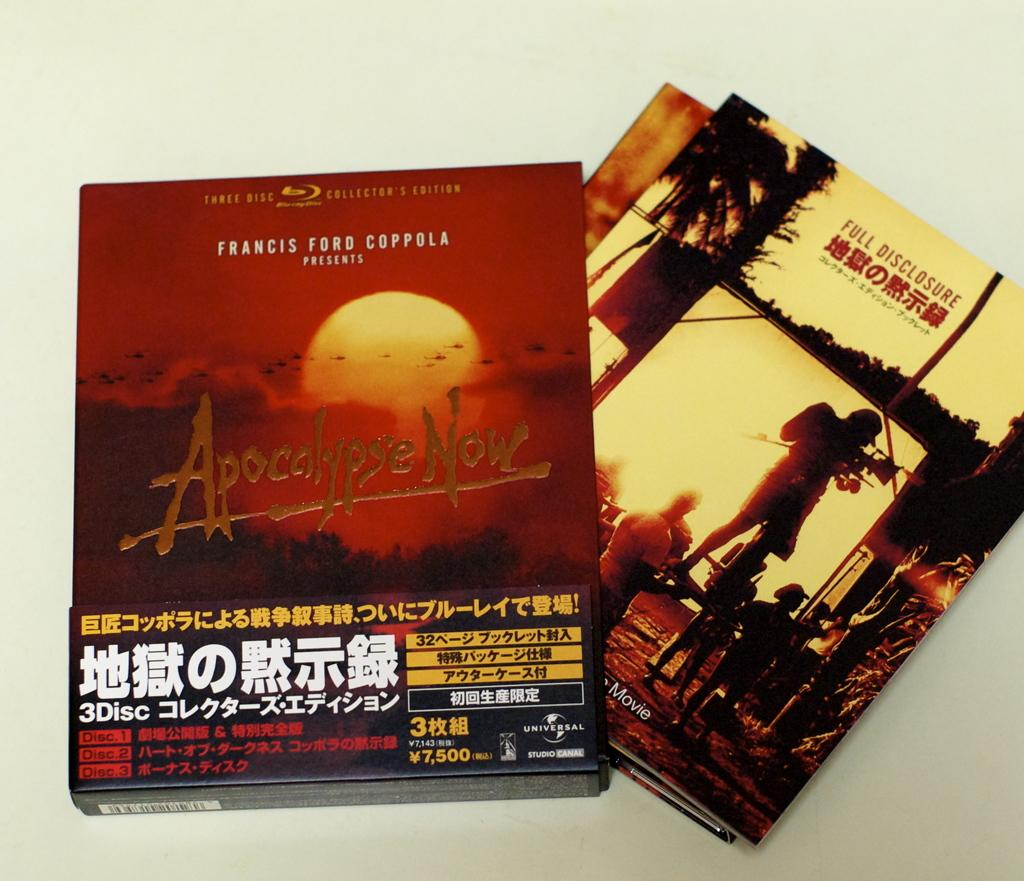<image>
Give a short and clear explanation of the subsequent image. The book with foreign writing is called Apocalypse Now. 